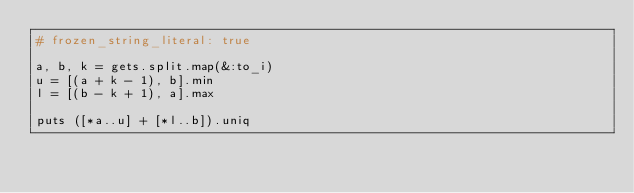Convert code to text. <code><loc_0><loc_0><loc_500><loc_500><_Ruby_># frozen_string_literal: true

a, b, k = gets.split.map(&:to_i)
u = [(a + k - 1), b].min
l = [(b - k + 1), a].max

puts ([*a..u] + [*l..b]).uniq</code> 